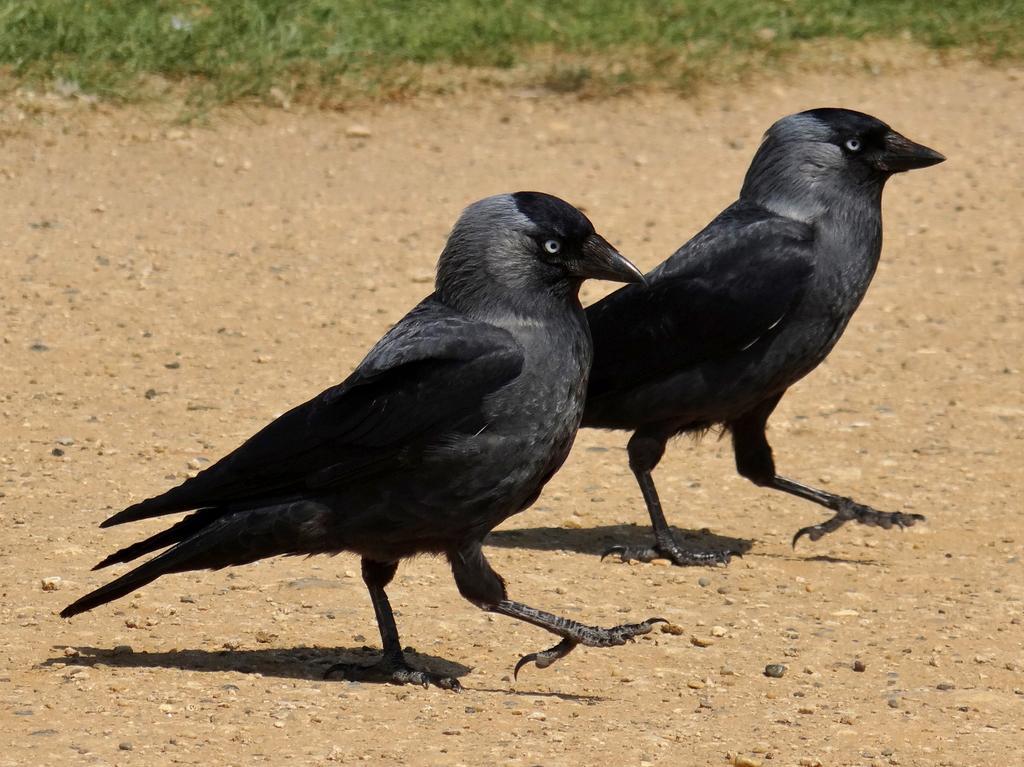Describe this image in one or two sentences. In this picture we can see two black crows standing on the path. There are tiny stones visible on the path. We can see some grass in the background. 